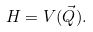<formula> <loc_0><loc_0><loc_500><loc_500>H = V ( \vec { Q } ) .</formula> 